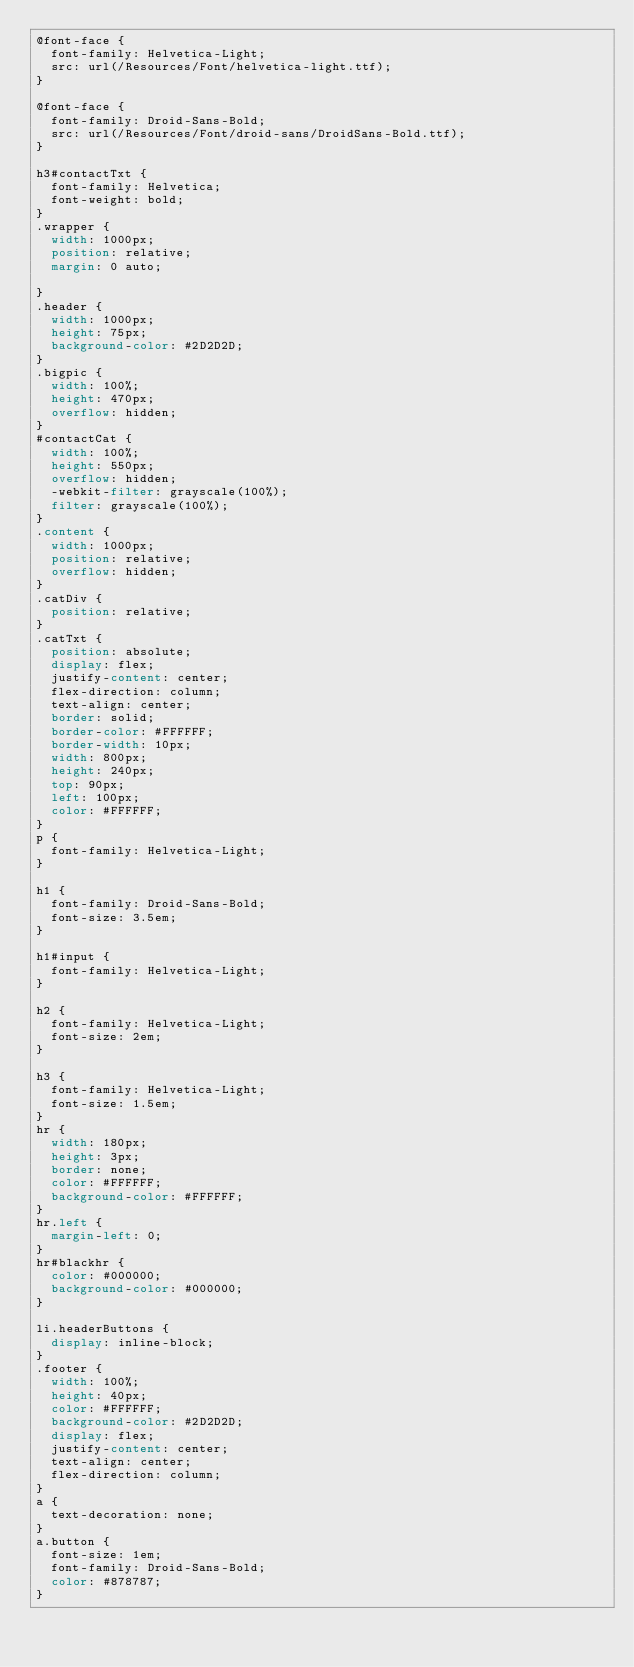<code> <loc_0><loc_0><loc_500><loc_500><_CSS_>@font-face {
  font-family: Helvetica-Light;
  src: url(/Resources/Font/helvetica-light.ttf);
}

@font-face {
  font-family: Droid-Sans-Bold;
  src: url(/Resources/Font/droid-sans/DroidSans-Bold.ttf);
}

h3#contactTxt {
  font-family: Helvetica;
  font-weight: bold;
}
.wrapper {
  width: 1000px;
  position: relative;
  margin: 0 auto;

}
.header {
  width: 1000px;
  height: 75px;
  background-color: #2D2D2D;
}
.bigpic {
  width: 100%;
  height: 470px;
  overflow: hidden;
}
#contactCat {
  width: 100%;
  height: 550px;
  overflow: hidden;
  -webkit-filter: grayscale(100%);
  filter: grayscale(100%);
}
.content {
  width: 1000px;
  position: relative;
  overflow: hidden;
}
.catDiv {
  position: relative;
}
.catTxt {
  position: absolute;
  display: flex;
  justify-content: center;
  flex-direction: column;
  text-align: center;
  border: solid;
  border-color: #FFFFFF;
  border-width: 10px;
  width: 800px;
  height: 240px;
  top: 90px;
  left: 100px;
  color: #FFFFFF;
}
p {
  font-family: Helvetica-Light;
}

h1 {
  font-family: Droid-Sans-Bold;
  font-size: 3.5em;
}

h1#input {
  font-family: Helvetica-Light;
}

h2 {
  font-family: Helvetica-Light;
  font-size: 2em;
}

h3 {
  font-family: Helvetica-Light;
  font-size: 1.5em;
}
hr {
  width: 180px;
  height: 3px;
  border: none;
  color: #FFFFFF;
  background-color: #FFFFFF;
}
hr.left {
  margin-left: 0;
}
hr#blackhr {
  color: #000000;
  background-color: #000000;
}

li.headerButtons {
  display: inline-block;
}
.footer {
  width: 100%;
  height: 40px;
  color: #FFFFFF;
  background-color: #2D2D2D;
  display: flex;
  justify-content: center;
  text-align: center;
  flex-direction: column;
}
a {
  text-decoration: none;
}
a.button {
  font-size: 1em;
  font-family: Droid-Sans-Bold;
  color: #878787;
}
</code> 